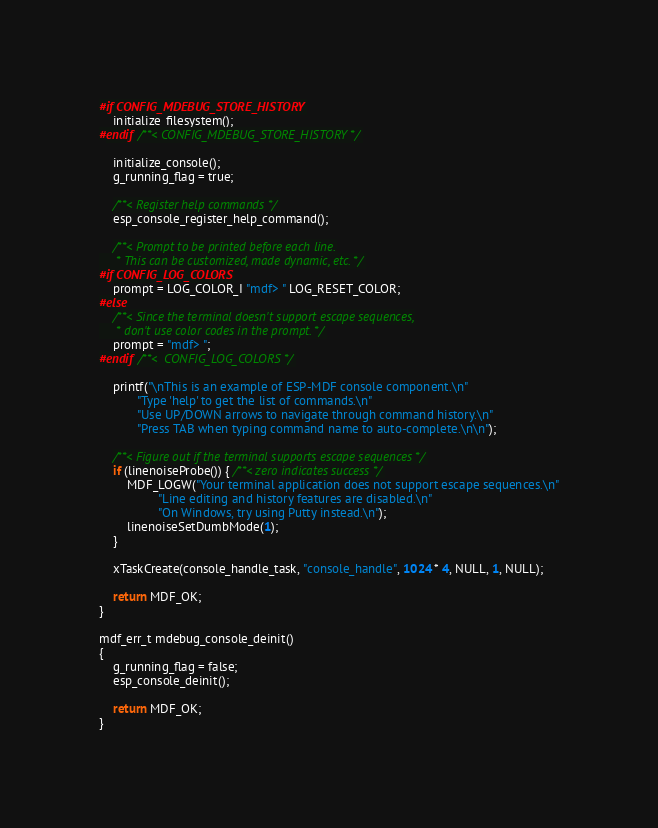Convert code to text. <code><loc_0><loc_0><loc_500><loc_500><_C_>#if CONFIG_MDEBUG_STORE_HISTORY
    initialize_filesystem();
#endif /**< CONFIG_MDEBUG_STORE_HISTORY */

    initialize_console();
    g_running_flag = true;

    /**< Register help commands */
    esp_console_register_help_command();

    /**< Prompt to be printed before each line.
     * This can be customized, made dynamic, etc. */
#if CONFIG_LOG_COLORS
    prompt = LOG_COLOR_I "mdf> " LOG_RESET_COLOR;
#else
    /**< Since the terminal doesn't support escape sequences,
     * don't use color codes in the prompt. */
    prompt = "mdf> ";
#endif /**<  CONFIG_LOG_COLORS */

    printf("\nThis is an example of ESP-MDF console component.\n"
           "Type 'help' to get the list of commands.\n"
           "Use UP/DOWN arrows to navigate through command history.\n"
           "Press TAB when typing command name to auto-complete.\n\n");

    /**< Figure out if the terminal supports escape sequences */
    if (linenoiseProbe()) { /**< zero indicates success */
        MDF_LOGW("Your terminal application does not support escape sequences.\n"
                 "Line editing and history features are disabled.\n"
                 "On Windows, try using Putty instead.\n");
        linenoiseSetDumbMode(1);
    }

    xTaskCreate(console_handle_task, "console_handle", 1024 * 4, NULL, 1, NULL);

    return MDF_OK;
}

mdf_err_t mdebug_console_deinit()
{
    g_running_flag = false;
    esp_console_deinit();

    return MDF_OK;
}
</code> 